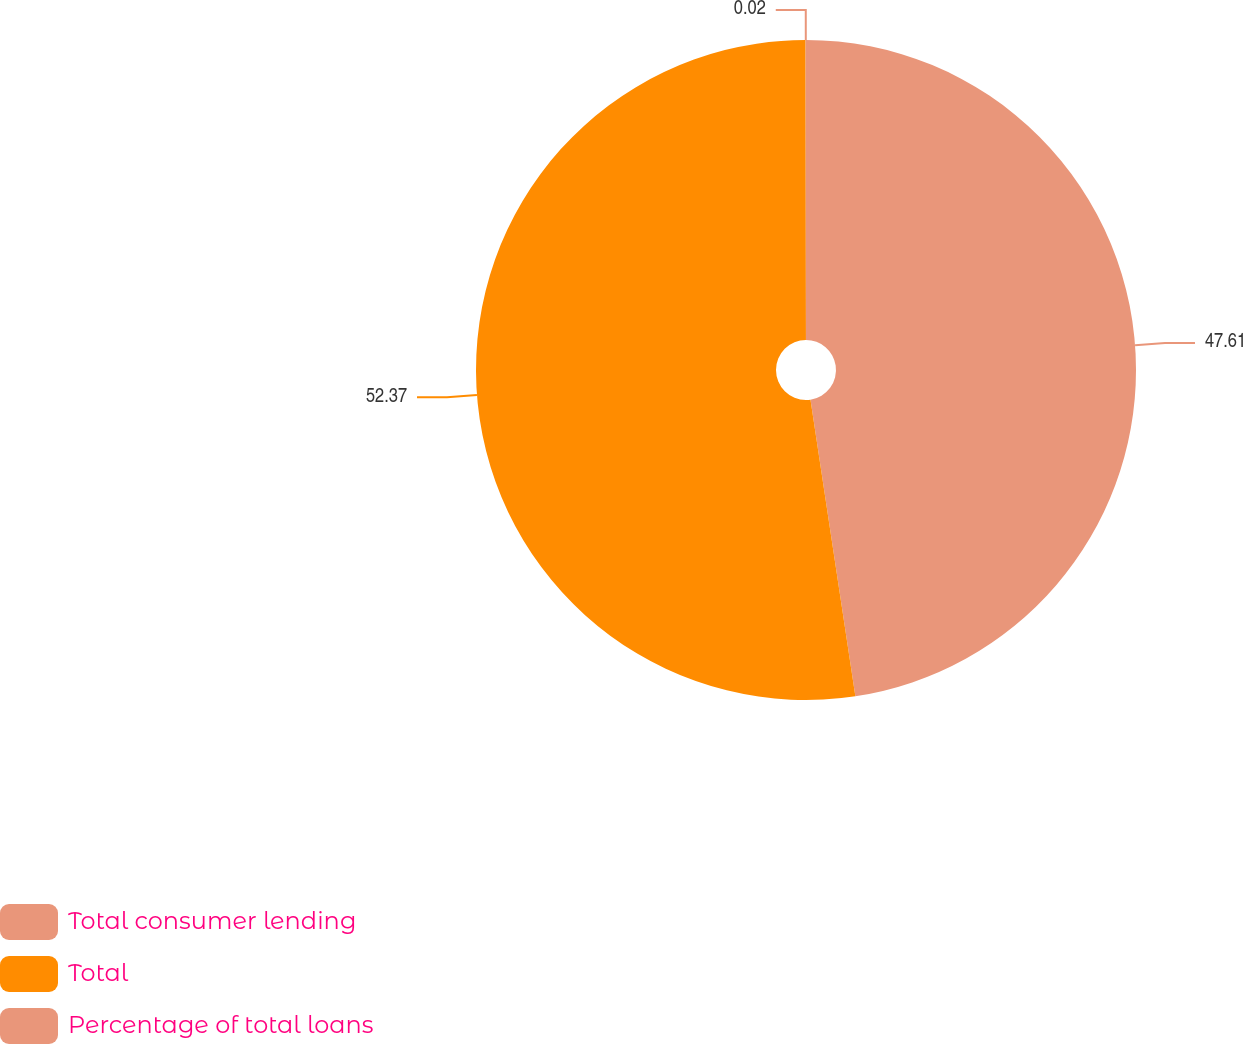Convert chart to OTSL. <chart><loc_0><loc_0><loc_500><loc_500><pie_chart><fcel>Total consumer lending<fcel>Total<fcel>Percentage of total loans<nl><fcel>47.61%<fcel>52.37%<fcel>0.02%<nl></chart> 